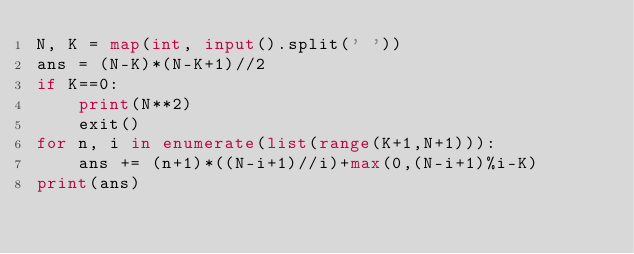Convert code to text. <code><loc_0><loc_0><loc_500><loc_500><_Python_>N, K = map(int, input().split(' '))
ans = (N-K)*(N-K+1)//2
if K==0:
    print(N**2)
    exit()
for n, i in enumerate(list(range(K+1,N+1))):
    ans += (n+1)*((N-i+1)//i)+max(0,(N-i+1)%i-K)
print(ans)</code> 